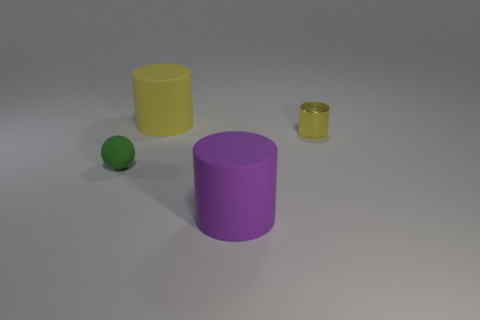What color is the cylinder that is both on the right side of the big yellow cylinder and left of the tiny metallic thing?
Your answer should be very brief. Purple. There is a big purple thing; are there any rubber objects behind it?
Provide a short and direct response. Yes. How many purple cylinders are behind the large thing in front of the yellow rubber object?
Offer a very short reply. 0. What is the size of the purple cylinder that is the same material as the tiny green ball?
Your answer should be compact. Large. How big is the metal object?
Give a very brief answer. Small. Is the large purple cylinder made of the same material as the sphere?
Offer a terse response. Yes. What number of spheres are yellow things or large purple objects?
Your response must be concise. 0. There is a tiny thing that is right of the big matte thing on the right side of the big yellow rubber object; what is its color?
Make the answer very short. Yellow. There is another object that is the same color as the tiny metal object; what size is it?
Give a very brief answer. Large. What number of big yellow cylinders are to the left of the big rubber thing to the right of the yellow thing that is left of the small cylinder?
Your response must be concise. 1. 